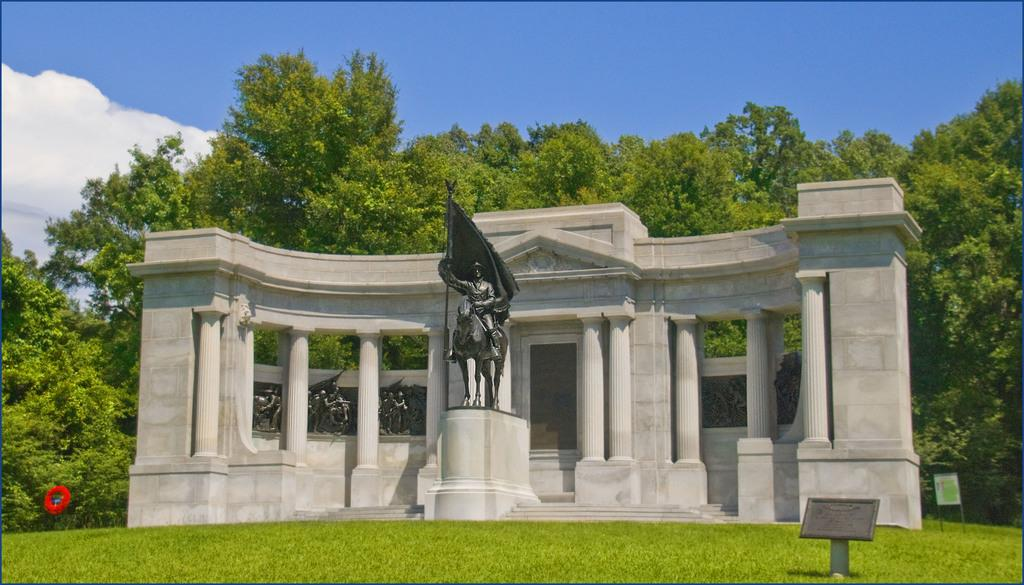What is the main subject in the image? There is a sculpture in the image. What architectural features can be seen in the image? There are pillars in the image, and they are connected to a wall. What type of vegetation is visible in the image? There are trees visible in the image. What type of feast is being prepared in the image? There is no indication of a feast or any food preparation in the image. 